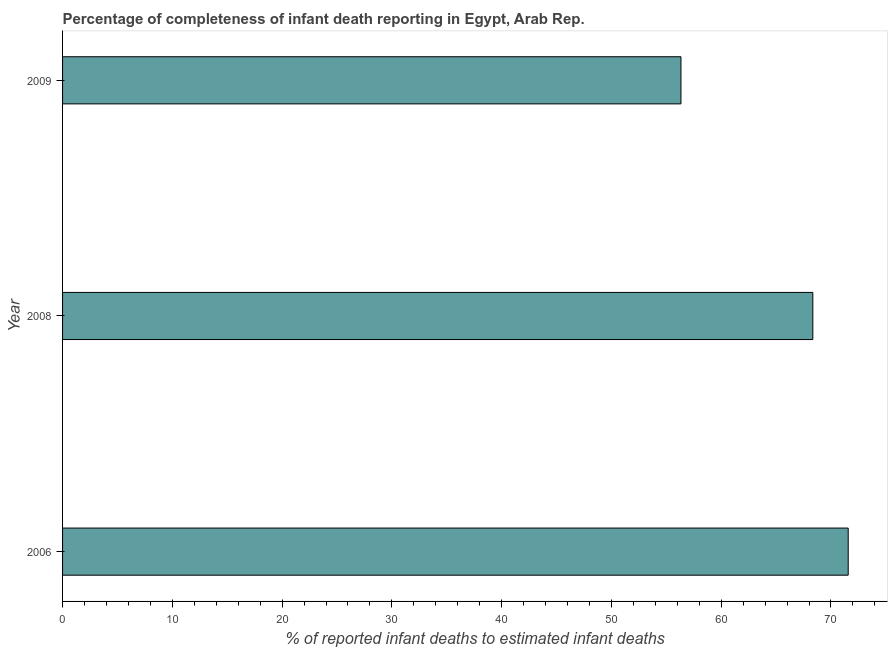Does the graph contain grids?
Offer a terse response. No. What is the title of the graph?
Your answer should be very brief. Percentage of completeness of infant death reporting in Egypt, Arab Rep. What is the label or title of the X-axis?
Your answer should be compact. % of reported infant deaths to estimated infant deaths. What is the label or title of the Y-axis?
Provide a succinct answer. Year. What is the completeness of infant death reporting in 2009?
Your answer should be very brief. 56.33. Across all years, what is the maximum completeness of infant death reporting?
Provide a succinct answer. 71.57. Across all years, what is the minimum completeness of infant death reporting?
Provide a short and direct response. 56.33. In which year was the completeness of infant death reporting minimum?
Give a very brief answer. 2009. What is the sum of the completeness of infant death reporting?
Your answer should be compact. 196.25. What is the difference between the completeness of infant death reporting in 2008 and 2009?
Provide a succinct answer. 12.01. What is the average completeness of infant death reporting per year?
Your response must be concise. 65.42. What is the median completeness of infant death reporting?
Your response must be concise. 68.35. In how many years, is the completeness of infant death reporting greater than 72 %?
Provide a succinct answer. 0. Do a majority of the years between 2008 and 2009 (inclusive) have completeness of infant death reporting greater than 72 %?
Offer a terse response. No. What is the ratio of the completeness of infant death reporting in 2006 to that in 2008?
Ensure brevity in your answer.  1.05. Is the completeness of infant death reporting in 2006 less than that in 2008?
Your answer should be very brief. No. What is the difference between the highest and the second highest completeness of infant death reporting?
Provide a succinct answer. 3.22. Is the sum of the completeness of infant death reporting in 2006 and 2008 greater than the maximum completeness of infant death reporting across all years?
Offer a terse response. Yes. What is the difference between the highest and the lowest completeness of infant death reporting?
Make the answer very short. 15.24. In how many years, is the completeness of infant death reporting greater than the average completeness of infant death reporting taken over all years?
Make the answer very short. 2. Are the values on the major ticks of X-axis written in scientific E-notation?
Offer a terse response. No. What is the % of reported infant deaths to estimated infant deaths in 2006?
Offer a very short reply. 71.57. What is the % of reported infant deaths to estimated infant deaths in 2008?
Offer a terse response. 68.35. What is the % of reported infant deaths to estimated infant deaths in 2009?
Ensure brevity in your answer.  56.33. What is the difference between the % of reported infant deaths to estimated infant deaths in 2006 and 2008?
Keep it short and to the point. 3.22. What is the difference between the % of reported infant deaths to estimated infant deaths in 2006 and 2009?
Offer a very short reply. 15.24. What is the difference between the % of reported infant deaths to estimated infant deaths in 2008 and 2009?
Keep it short and to the point. 12.01. What is the ratio of the % of reported infant deaths to estimated infant deaths in 2006 to that in 2008?
Keep it short and to the point. 1.05. What is the ratio of the % of reported infant deaths to estimated infant deaths in 2006 to that in 2009?
Give a very brief answer. 1.27. What is the ratio of the % of reported infant deaths to estimated infant deaths in 2008 to that in 2009?
Provide a short and direct response. 1.21. 